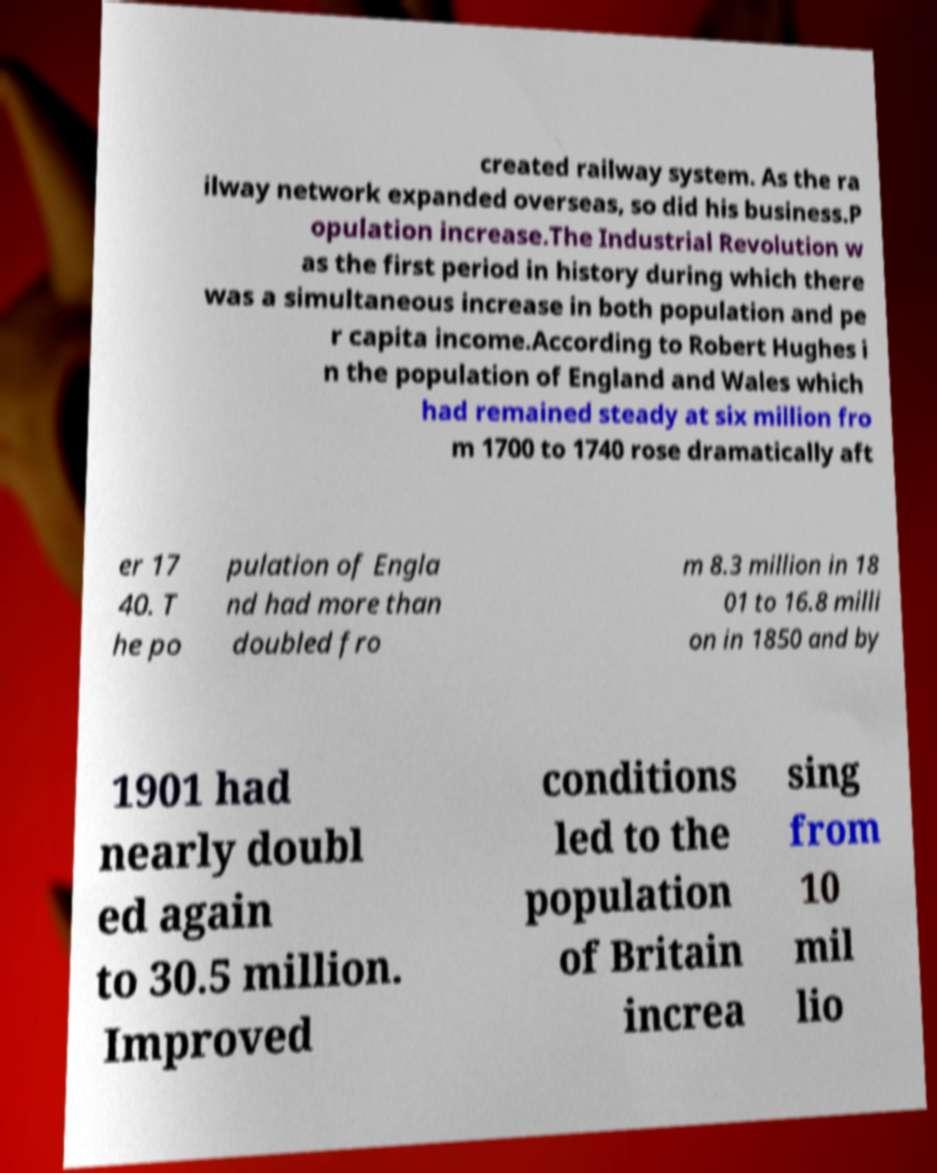What messages or text are displayed in this image? I need them in a readable, typed format. created railway system. As the ra ilway network expanded overseas, so did his business.P opulation increase.The Industrial Revolution w as the first period in history during which there was a simultaneous increase in both population and pe r capita income.According to Robert Hughes i n the population of England and Wales which had remained steady at six million fro m 1700 to 1740 rose dramatically aft er 17 40. T he po pulation of Engla nd had more than doubled fro m 8.3 million in 18 01 to 16.8 milli on in 1850 and by 1901 had nearly doubl ed again to 30.5 million. Improved conditions led to the population of Britain increa sing from 10 mil lio 